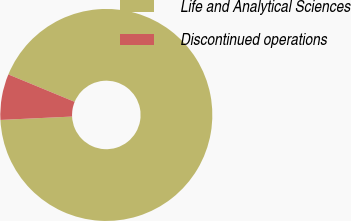Convert chart to OTSL. <chart><loc_0><loc_0><loc_500><loc_500><pie_chart><fcel>Life and Analytical Sciences<fcel>Discontinued operations<nl><fcel>93.01%<fcel>6.99%<nl></chart> 